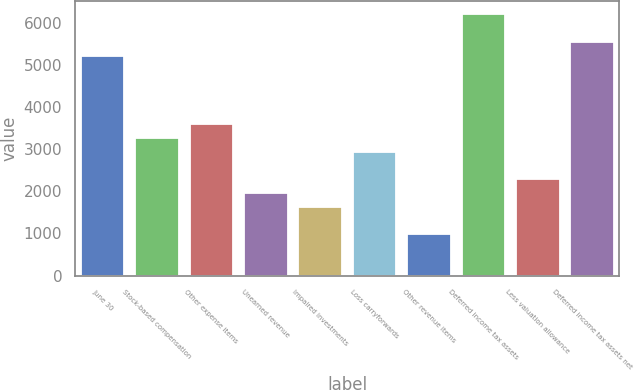Convert chart to OTSL. <chart><loc_0><loc_0><loc_500><loc_500><bar_chart><fcel>June 30<fcel>Stock-based compensation<fcel>Other expense items<fcel>Unearned revenue<fcel>Impaired investments<fcel>Loss carryforwards<fcel>Other revenue items<fcel>Deferred income tax assets<fcel>Less valuation allowance<fcel>Deferred income tax assets net<nl><fcel>5224.4<fcel>3266<fcel>3592.4<fcel>1960.4<fcel>1634<fcel>2939.6<fcel>981.2<fcel>6203.6<fcel>2286.8<fcel>5550.8<nl></chart> 